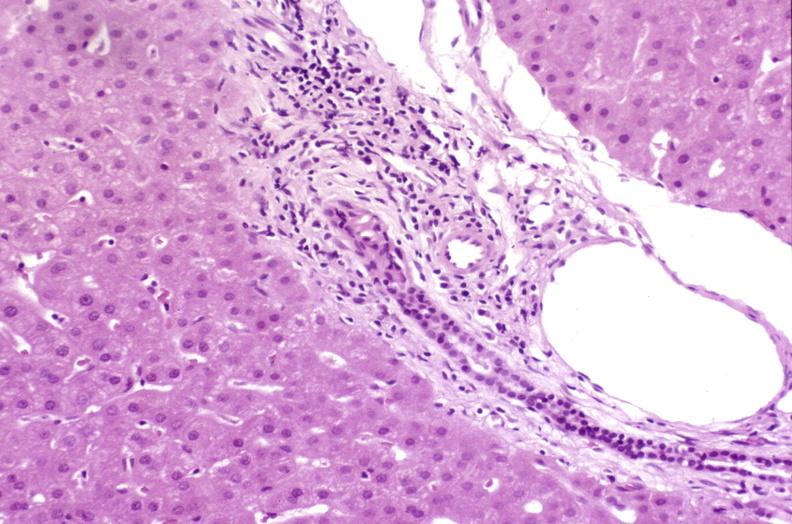does this image show resolving acute rejection?
Answer the question using a single word or phrase. Yes 